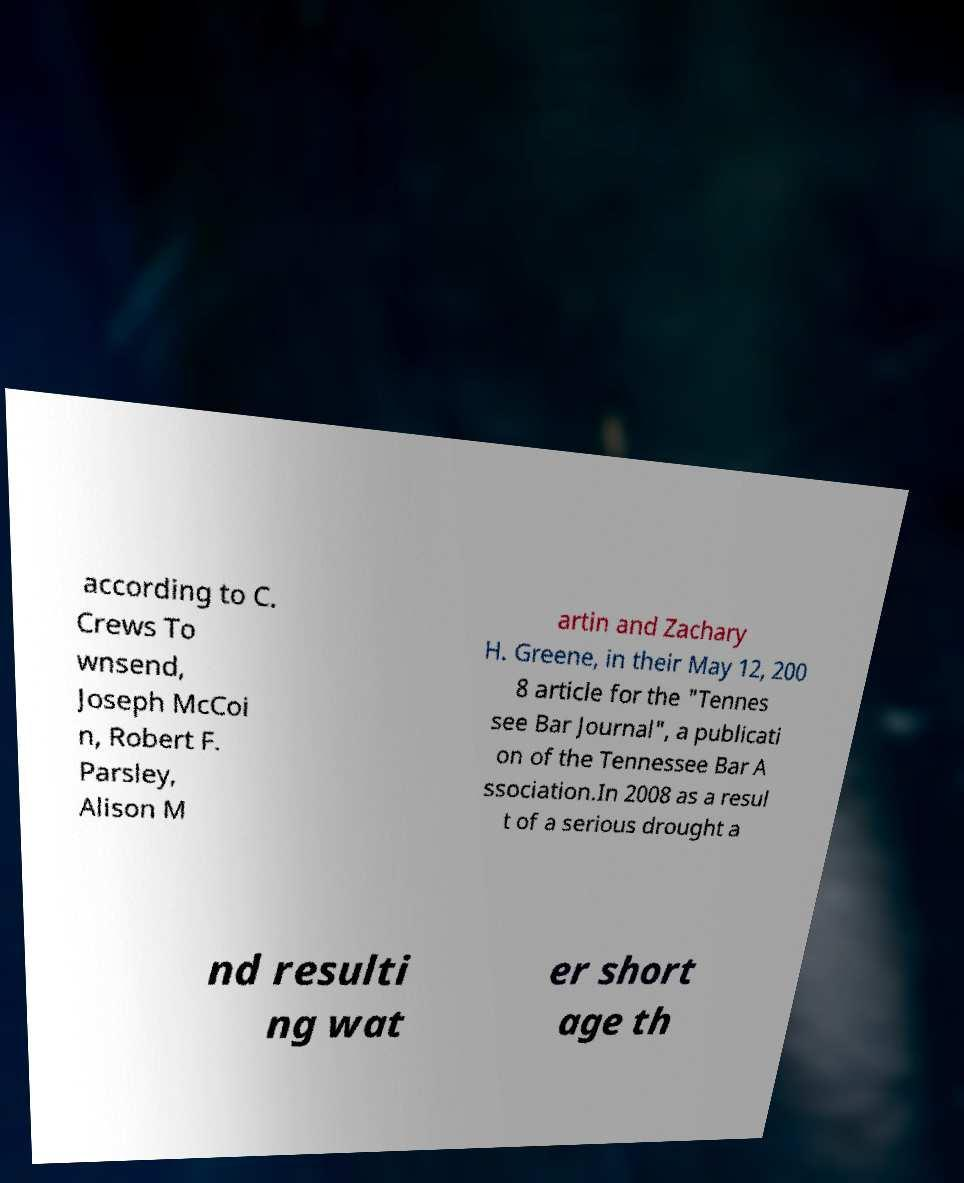I need the written content from this picture converted into text. Can you do that? according to C. Crews To wnsend, Joseph McCoi n, Robert F. Parsley, Alison M artin and Zachary H. Greene, in their May 12, 200 8 article for the "Tennes see Bar Journal", a publicati on of the Tennessee Bar A ssociation.In 2008 as a resul t of a serious drought a nd resulti ng wat er short age th 